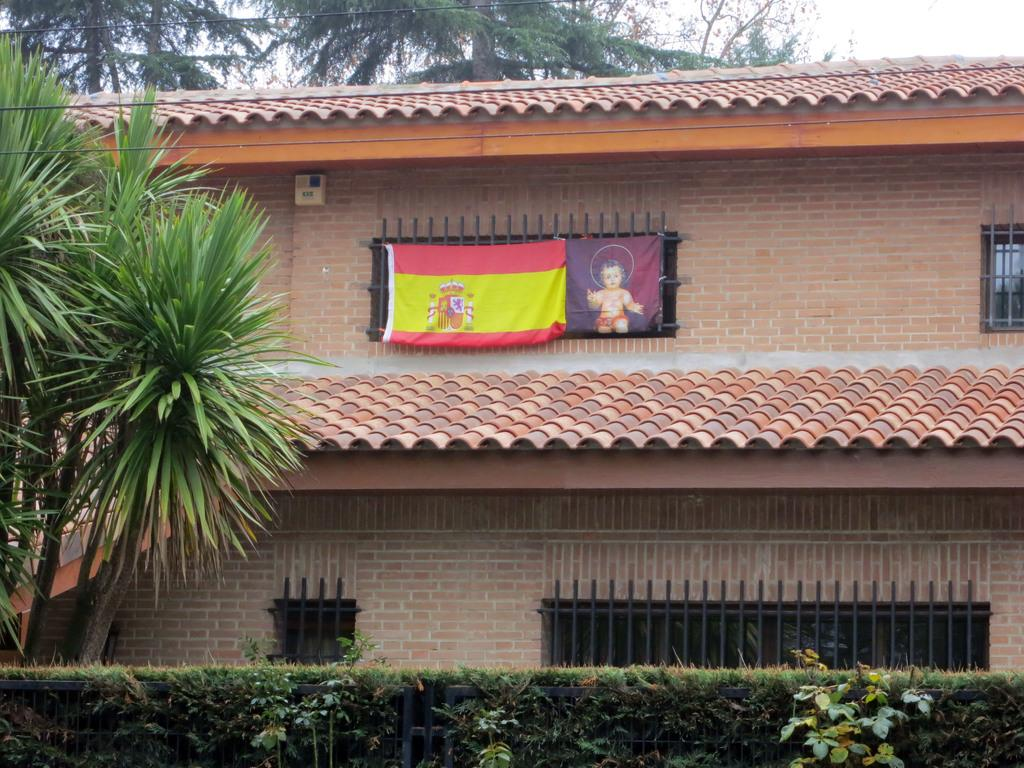What type of structure is visible in the image? There is a building in the image. What can be seen at the bottom of the image? Plants are present at the bottom of the image. Where are trees located in the image? Trees are visible on the left side and at the top of the image. How many sisters are playing a record in the image? There are no sisters or records present in the image. 